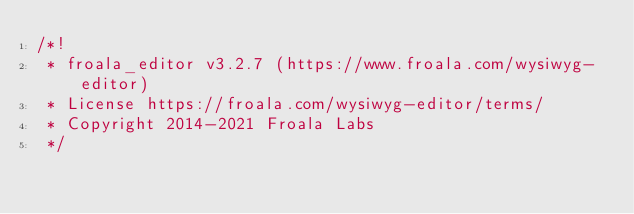Convert code to text. <code><loc_0><loc_0><loc_500><loc_500><_CSS_>/*!
 * froala_editor v3.2.7 (https://www.froala.com/wysiwyg-editor)
 * License https://froala.com/wysiwyg-editor/terms/
 * Copyright 2014-2021 Froala Labs
 */
</code> 